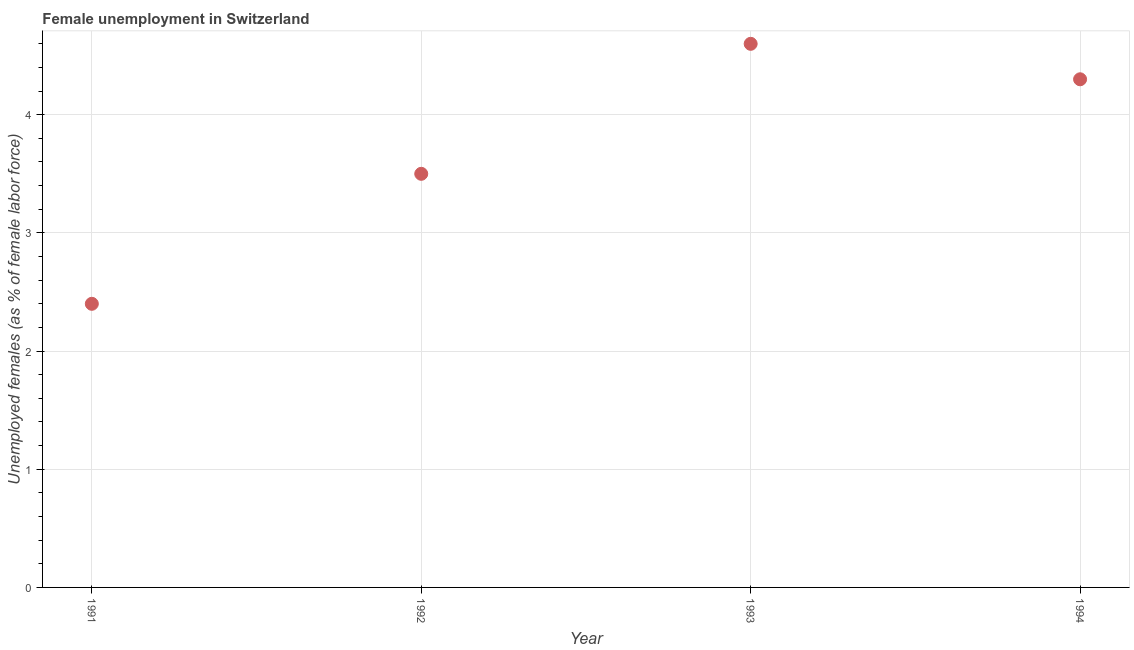What is the unemployed females population in 1991?
Your answer should be very brief. 2.4. Across all years, what is the maximum unemployed females population?
Give a very brief answer. 4.6. Across all years, what is the minimum unemployed females population?
Offer a terse response. 2.4. In which year was the unemployed females population maximum?
Offer a very short reply. 1993. In which year was the unemployed females population minimum?
Ensure brevity in your answer.  1991. What is the sum of the unemployed females population?
Provide a succinct answer. 14.8. What is the difference between the unemployed females population in 1991 and 1993?
Make the answer very short. -2.2. What is the average unemployed females population per year?
Keep it short and to the point. 3.7. What is the median unemployed females population?
Offer a very short reply. 3.9. In how many years, is the unemployed females population greater than 0.8 %?
Ensure brevity in your answer.  4. What is the ratio of the unemployed females population in 1991 to that in 1993?
Offer a very short reply. 0.52. Is the difference between the unemployed females population in 1991 and 1994 greater than the difference between any two years?
Your answer should be compact. No. What is the difference between the highest and the second highest unemployed females population?
Offer a very short reply. 0.3. What is the difference between the highest and the lowest unemployed females population?
Offer a terse response. 2.2. In how many years, is the unemployed females population greater than the average unemployed females population taken over all years?
Your response must be concise. 2. Does the unemployed females population monotonically increase over the years?
Offer a terse response. No. How many dotlines are there?
Ensure brevity in your answer.  1. What is the difference between two consecutive major ticks on the Y-axis?
Provide a succinct answer. 1. Does the graph contain any zero values?
Provide a succinct answer. No. Does the graph contain grids?
Your response must be concise. Yes. What is the title of the graph?
Keep it short and to the point. Female unemployment in Switzerland. What is the label or title of the X-axis?
Provide a short and direct response. Year. What is the label or title of the Y-axis?
Offer a terse response. Unemployed females (as % of female labor force). What is the Unemployed females (as % of female labor force) in 1991?
Provide a succinct answer. 2.4. What is the Unemployed females (as % of female labor force) in 1993?
Give a very brief answer. 4.6. What is the Unemployed females (as % of female labor force) in 1994?
Keep it short and to the point. 4.3. What is the difference between the Unemployed females (as % of female labor force) in 1992 and 1993?
Offer a terse response. -1.1. What is the ratio of the Unemployed females (as % of female labor force) in 1991 to that in 1992?
Offer a very short reply. 0.69. What is the ratio of the Unemployed females (as % of female labor force) in 1991 to that in 1993?
Your answer should be very brief. 0.52. What is the ratio of the Unemployed females (as % of female labor force) in 1991 to that in 1994?
Make the answer very short. 0.56. What is the ratio of the Unemployed females (as % of female labor force) in 1992 to that in 1993?
Give a very brief answer. 0.76. What is the ratio of the Unemployed females (as % of female labor force) in 1992 to that in 1994?
Provide a short and direct response. 0.81. What is the ratio of the Unemployed females (as % of female labor force) in 1993 to that in 1994?
Provide a short and direct response. 1.07. 